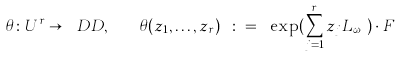Convert formula to latex. <formula><loc_0><loc_0><loc_500><loc_500>\theta \colon U ^ { r } \rightarrow \ D D , \quad \theta ( z _ { 1 } , \dots , z _ { r } ) \ \colon = \ \exp ( \sum _ { j = 1 } ^ { r } z _ { j } L _ { \omega _ { j } } ) \cdot F</formula> 